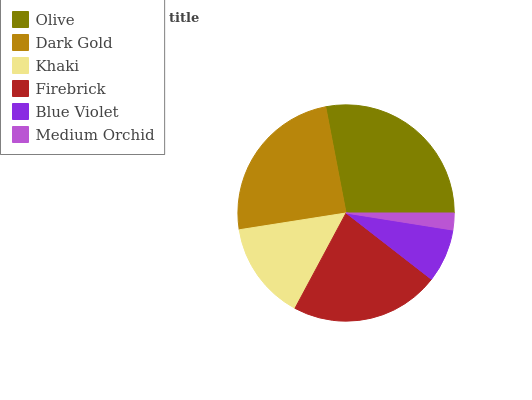Is Medium Orchid the minimum?
Answer yes or no. Yes. Is Olive the maximum?
Answer yes or no. Yes. Is Dark Gold the minimum?
Answer yes or no. No. Is Dark Gold the maximum?
Answer yes or no. No. Is Olive greater than Dark Gold?
Answer yes or no. Yes. Is Dark Gold less than Olive?
Answer yes or no. Yes. Is Dark Gold greater than Olive?
Answer yes or no. No. Is Olive less than Dark Gold?
Answer yes or no. No. Is Firebrick the high median?
Answer yes or no. Yes. Is Khaki the low median?
Answer yes or no. Yes. Is Medium Orchid the high median?
Answer yes or no. No. Is Olive the low median?
Answer yes or no. No. 